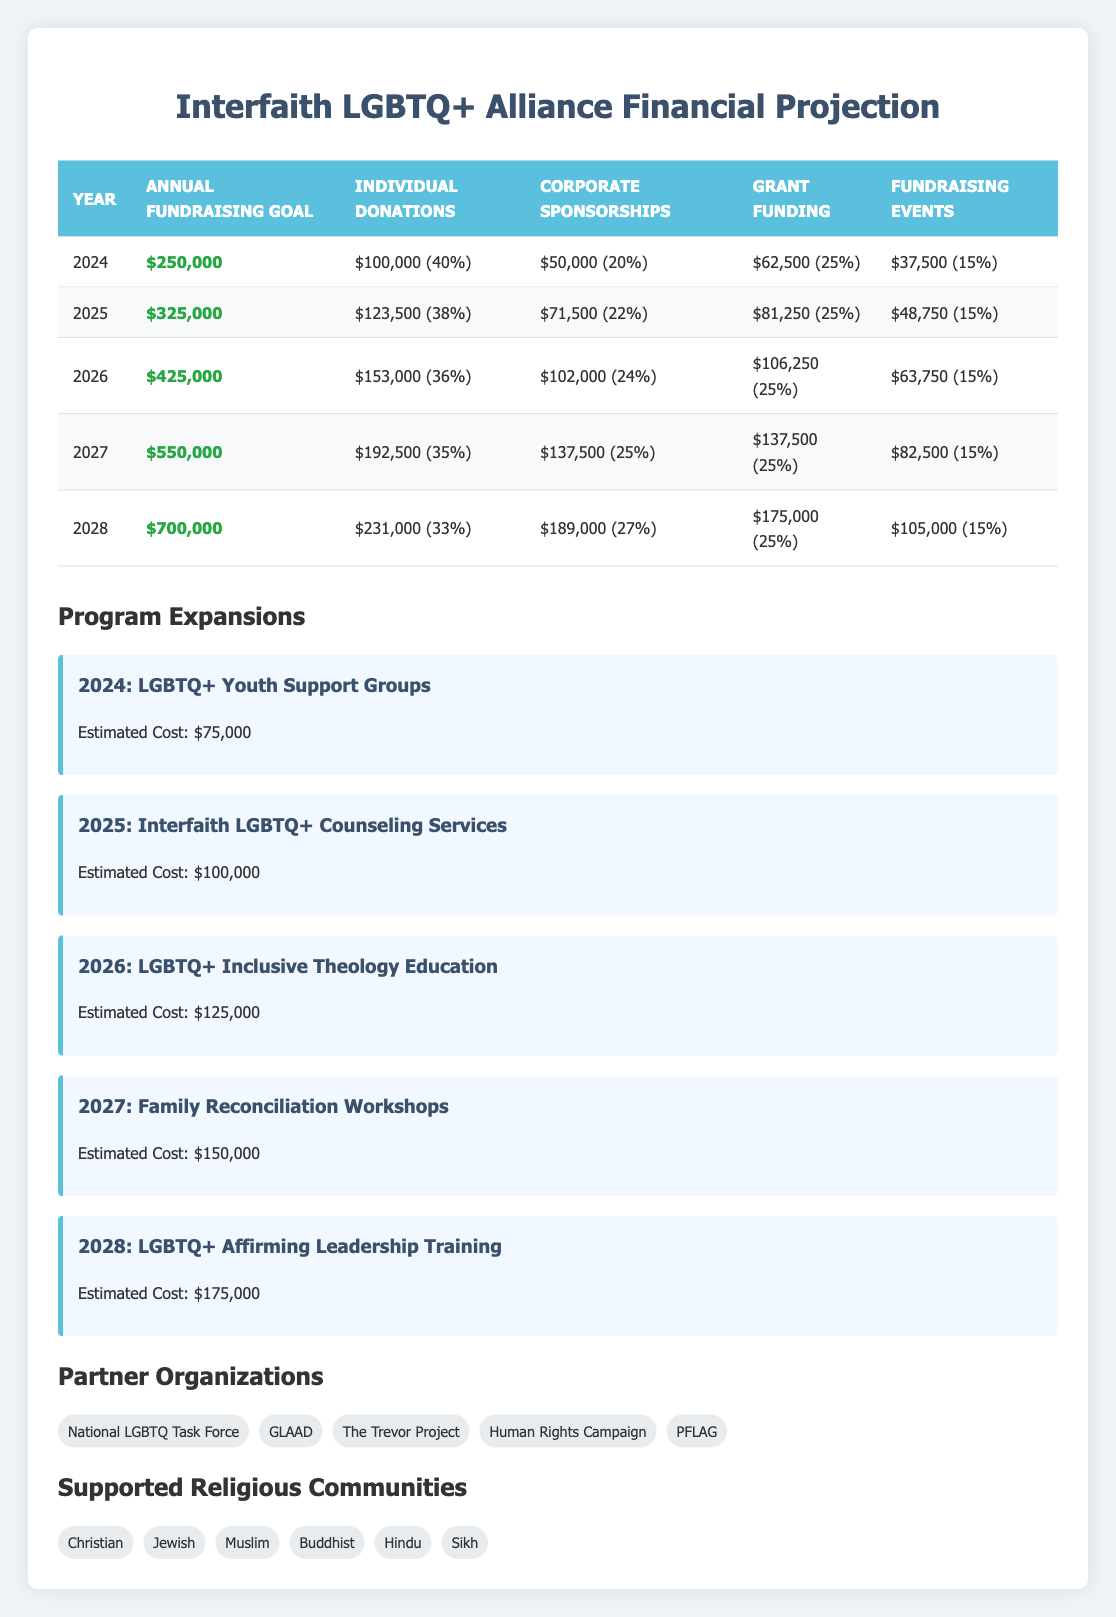What is the annual fundraising goal for 2025? The annual fundraising goal for 2025 is listed directly in the table under that year. It is $325,000.
Answer: $325,000 In which year is the program for LGBTQ+ Inclusive Theology Education set to launch? The table shows program expansions with their respective years. LGBTQ+ Inclusive Theology Education is planned for 2026.
Answer: 2026 What percentage of the total fundraising goal is expected from Individual Donations in 2027? The table shows the percentage of the total fundraising goal derived from Individual Donations for each year. In 2027, it is 35%.
Answer: 35% How much additional funding is needed in 2028 compared to 2024? The goals for 2028 and 2024 are $700,000 and $250,000, respectively. To find the additional funding needed, subtract the 2024 goal from the 2028 goal: $700,000 - $250,000 = $450,000.
Answer: $450,000 Is the funding from Corporate Sponsorships increasing in every year from 2024 to 2028? Examining the table shows that corporate sponsorships go from 20% in 2024 to 27% in 2028, indicating an increase. Thus, the statement is true.
Answer: Yes What is the total estimated cost of all program expansions over the five years? The estimated costs for each program expansion are: $75,000 (2024), $100,000 (2025), $125,000 (2026), $150,000 (2027), and $175,000 (2028). Adding these gives: $75,000 + $100,000 + $125,000 + $150,000 + $175,000 = $625,000.
Answer: $625,000 Which funding source has the highest percentage of total expected funding in 2026? In 2026, the funding sources and their respective percentages are: Individual Donations (36%), Corporate Sponsorships (24%), Grant Funding (25%), and Fundraising Events (15%). The highest percentage is from Individual Donations at 36%.
Answer: Individual Donations How much will the revenue from Fundraising Events increase from 2024 to 2028? In 2024, the revenue from Fundraising Events is $37,500 (15% of $250,000), and in 2028 it is $105,000 (15% of $700,000). The increase is calculated as $105,000 - $37,500 = $67,500.
Answer: $67,500 What proportion of the total fundraising goal for 2026 comes from Grant Funding? The goal for 2026 is $425,000, and Grant Funding is 25% of this, which is calculated as $425,000 * 0.25 = $106,250. The proportion is 25%.
Answer: 25% 